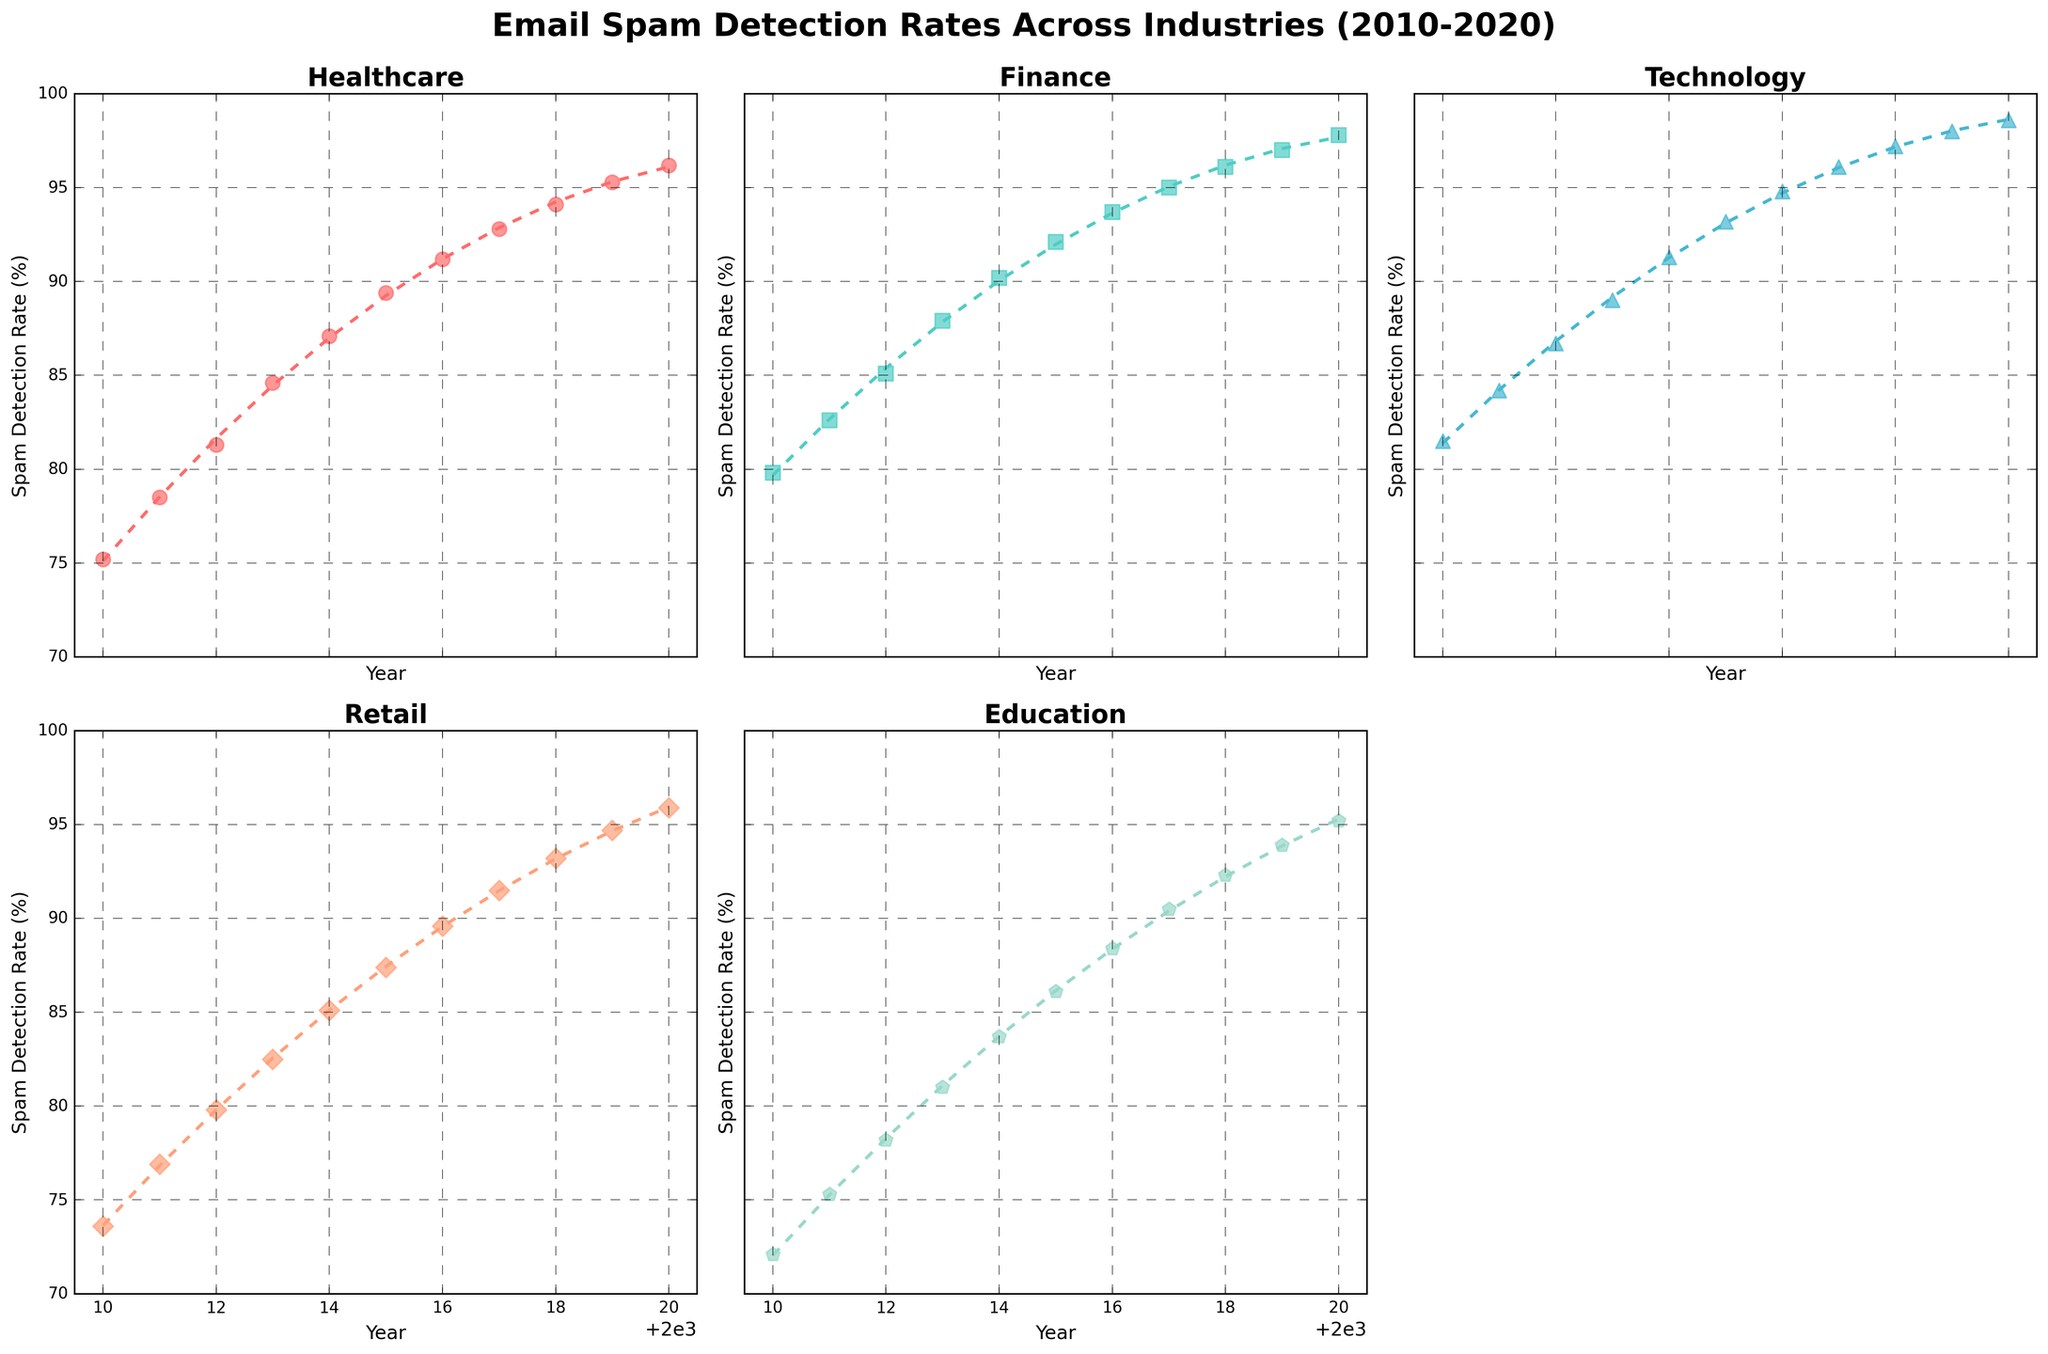what year did Healthcare reach a spam detection rate of over 90%? The subplot for Healthcare shows the spam detection rates over time. Looking at the scatter plot, Healthcare surpassed a 90% spam detection rate in 2016.
Answer: 2016 Which industry had the highest spam detection rate in 2018? Reviewing the scatter plots for all industries in 2018, Technology had the highest spam detection rate.
Answer: Technology What is the trend of spam detection rates in Retail from 2010 to 2020? Observing the subplot for Retail, the trend is consistently upward from 73.6% in 2010 to 95.9% in 2020, as indicated by the scatter plot and the polynomial trendline.
Answer: Upward trend Compare the spam detection rates of Education and Finance in 2012. Which one is higher and by how much? The Education rate in 2012 was 78.2%, while Finance was at 85.1%. Subtracting these, Finance had a higher spam detection rate by 6.9%.
Answer: Finance, by 6.9% Did any industry reach a spam detection rate of 98% by 2020? Checking each subplot, Technology is the only industry that reached a 98% spam detection rate in 2020.
Answer: Yes, Technology What year did Finance first surpass a spam detection rate of 90%? Examining Finance's subplot, it first exceeded 90% in 2014.
Answer: 2014 Which industry showed the most improvement in spam detection rate between 2010 and 2020? Calculating the difference in spam detection rates from 2010 to 2020 for each industry, Retail improved by 22.3%, which is the highest increase among all industries.
Answer: Retail In what year did the Technology industry have a spam detection rate lower than Healthcare? Comparing the subplots, in 2010, Technology had a rate of 81.5%, slightly higher than Healthcare at 75.2%. Hence, Technology did not have a lower rate than Healthcare during the entire period.
Answer: Never Compare the overall trends in spam detection rates between Healthcare and Education. Which industry shows a steeper increase? By analyzing both subplots and their polynomial trendlines, Healthcare shows a steeper increase from 75.2% to 96.2%, while Education moves from 72.1% to 95.2%.
Answer: Healthcare Which industry had the lowest initial spam detection rate in 2010 and what was it? Checking the initial rates from each subplot, Education recorded the lowest initial spam detection rate in 2010 at 72.1%.
Answer: Education, 72.1% 